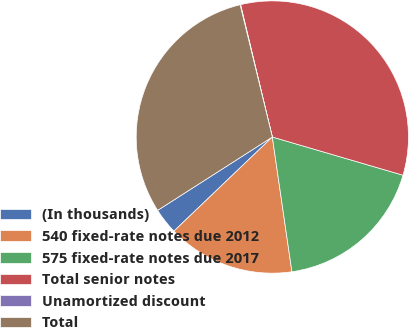Convert chart. <chart><loc_0><loc_0><loc_500><loc_500><pie_chart><fcel>(In thousands)<fcel>540 fixed-rate notes due 2012<fcel>575 fixed-rate notes due 2017<fcel>Total senior notes<fcel>Unamortized discount<fcel>Total<nl><fcel>3.09%<fcel>15.15%<fcel>18.18%<fcel>33.27%<fcel>0.06%<fcel>30.25%<nl></chart> 